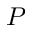Convert formula to latex. <formula><loc_0><loc_0><loc_500><loc_500>P</formula> 